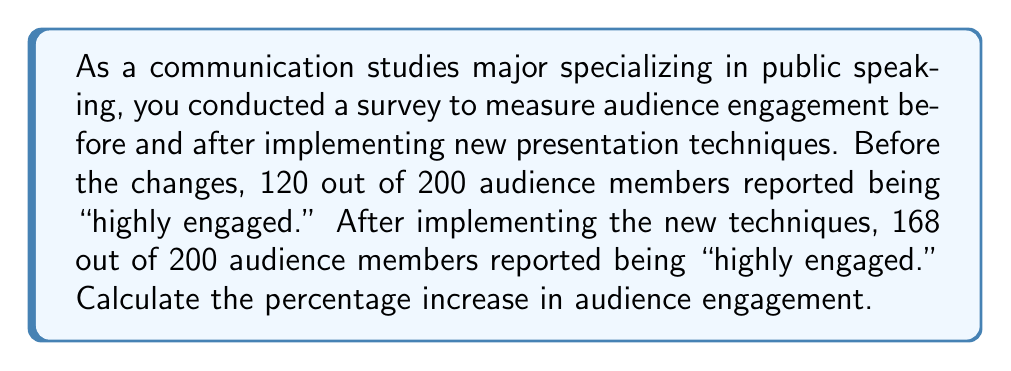Show me your answer to this math problem. To solve this problem, we need to follow these steps:

1. Calculate the initial percentage of highly engaged audience members:
   $$\text{Initial Percentage} = \frac{120}{200} \times 100\% = 60\%$$

2. Calculate the final percentage of highly engaged audience members:
   $$\text{Final Percentage} = \frac{168}{200} \times 100\% = 84\%$$

3. Calculate the difference between the final and initial percentages:
   $$\text{Difference} = 84\% - 60\% = 24\%$$

4. Calculate the percentage increase using the formula:
   $$\text{Percentage Increase} = \frac{\text{Increase}}{\text{Original Value}} \times 100\%$$
   
   $$\text{Percentage Increase} = \frac{24\%}{60\%} \times 100\% = 0.4 \times 100\% = 40\%$$

Therefore, the percentage increase in audience engagement is 40%.
Answer: 40% 